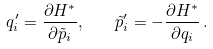Convert formula to latex. <formula><loc_0><loc_0><loc_500><loc_500>q _ { i } ^ { \prime } = \frac { \partial H ^ { * } } { \partial \tilde { p } _ { i } } , \quad \tilde { p } _ { i } ^ { \prime } = - \frac { \partial H ^ { * } } { \partial q _ { i } } \, .</formula> 